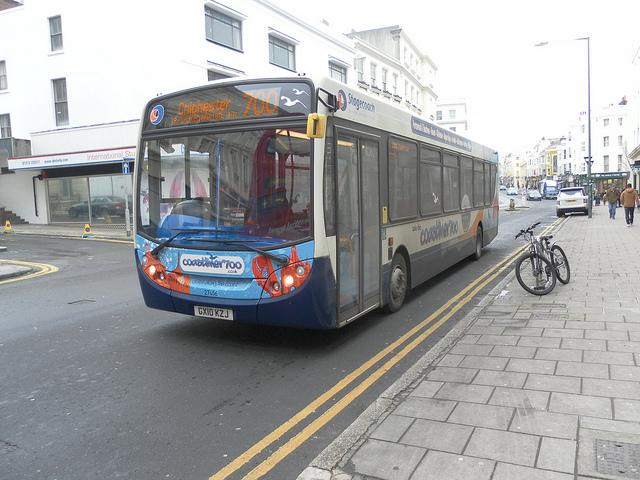Which vehicle has violated the law?

Choices:
A) white car
B) black car
C) bicycle
D) bus white car 